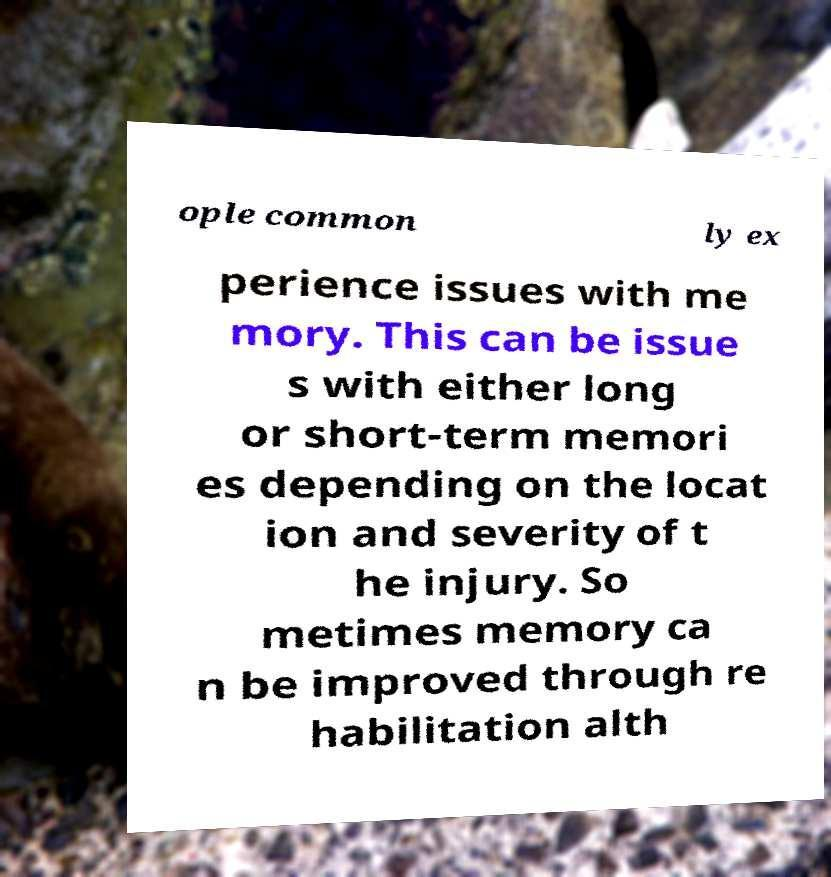Please identify and transcribe the text found in this image. ople common ly ex perience issues with me mory. This can be issue s with either long or short-term memori es depending on the locat ion and severity of t he injury. So metimes memory ca n be improved through re habilitation alth 